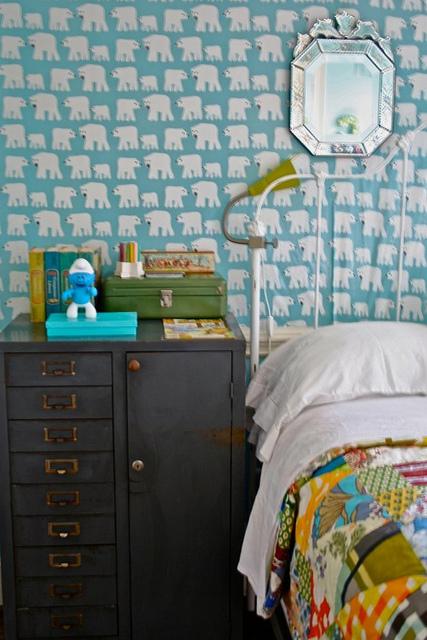What print is on the wallpaper?
Answer briefly. Polar bears. What is behind the bed?
Be succinct. Mirror. How many knobs?
Write a very short answer. 2. What toy is on the dresser?
Quick response, please. Smurf. 